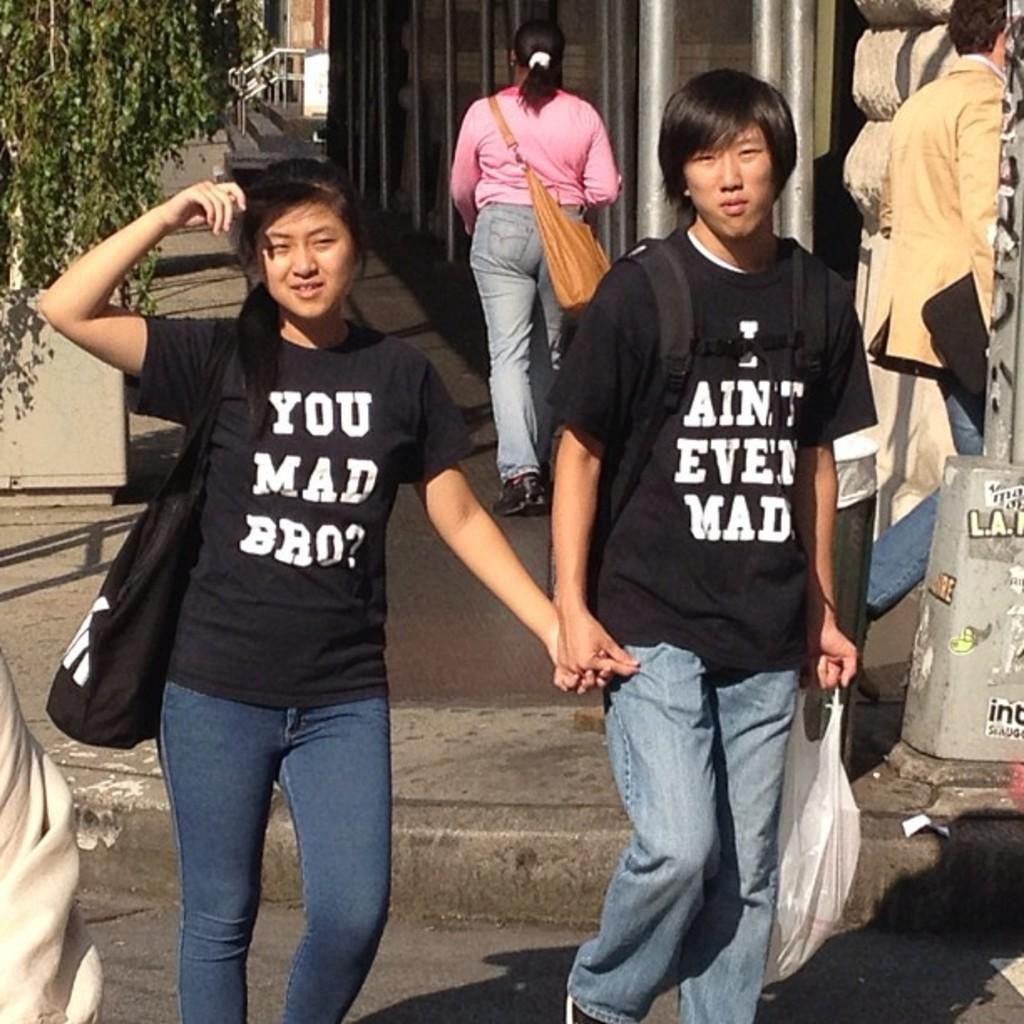How would you summarize this image in a sentence or two? In this image, we can see few people are walking. Few are wearing bags and holding some objects. At the bottom, there is a road. Background we can see few plants, pole, rods and walkway. 